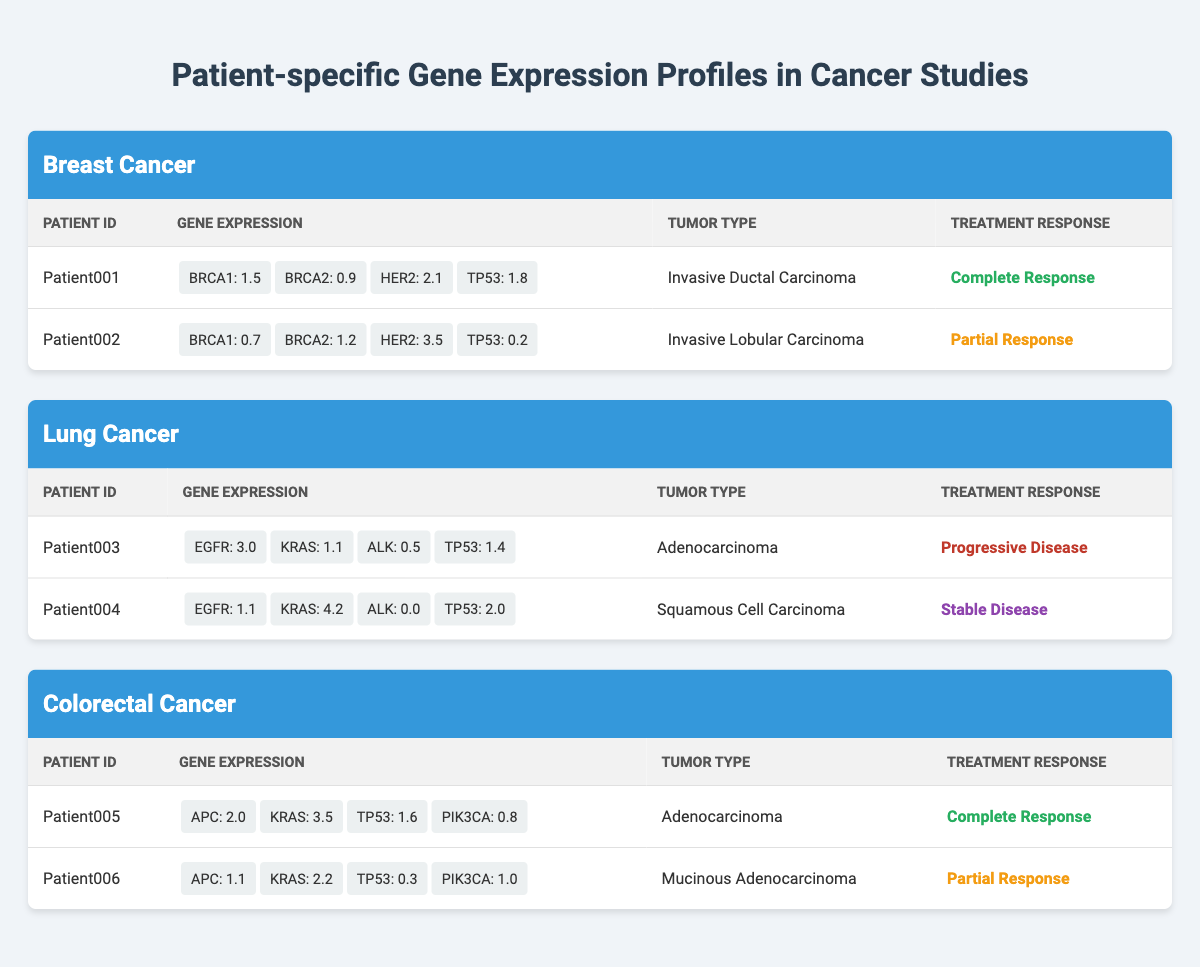What is the gene expression level of BRCA1 in Patient001? The gene expression data for Patient001 shows that the level of BRCA1 is 1.5.
Answer: 1.5 Which patient has the highest expression of HER2? Patient002 has HER2 expression at 3.5, which is higher than Patient001's HER2 at 2.1.
Answer: Patient002 Is TP53 expression higher in Patient004 than in Patient003? The expression of TP53 in Patient004 is 2.0, while in Patient003 it is 1.4, making it higher in Patient004.
Answer: Yes What is the treatment response for Patient005 and Patient006? Patient005 has a treatment response of "Complete Response", whereas Patient006 has "Partial Response".
Answer: Complete Response and Partial Response What is the total gene expression level for KRAS across all patients in the Lung Cancer study? In the Lung Cancer section, Patient003 has a KRAS expression of 1.1 and Patient004 has 4.2. Adding these gives 1.1 + 4.2 = 5.3.
Answer: 5.3 Which tumor type does Patient001 have? Looking at the data, Patient001 is diagnosed with "Invasive Ductal Carcinoma".
Answer: Invasive Ductal Carcinoma Which patient has the lowest expression of PIK3CA? Patient006 has PIK3CA at 1.0, while Patient005 has it at 0.8. Therefore, Patient006 has the lowest value.
Answer: Patient006 Is there a patient with a "Progressive Disease" response in the Colorectal Cancer study? There are only two patients listed under Colorectal Cancer, and both have "Complete Response" and "Partial Response", so there is none with "Progressive Disease".
Answer: No What is the average expression level of EGFR in Lung Cancer patients? Patient003 has EGFR at 3.0 and Patient004 at 1.1. To find the average, sum these values (3.0 + 1.1) = 4.1 and then divide by 2, so the average is 4.1 / 2 = 2.05.
Answer: 2.05 What is the tumor type for Patient003? The data shows that Patient003 has a tumor type labeled "Adenocarcinoma".
Answer: Adenocarcinoma 